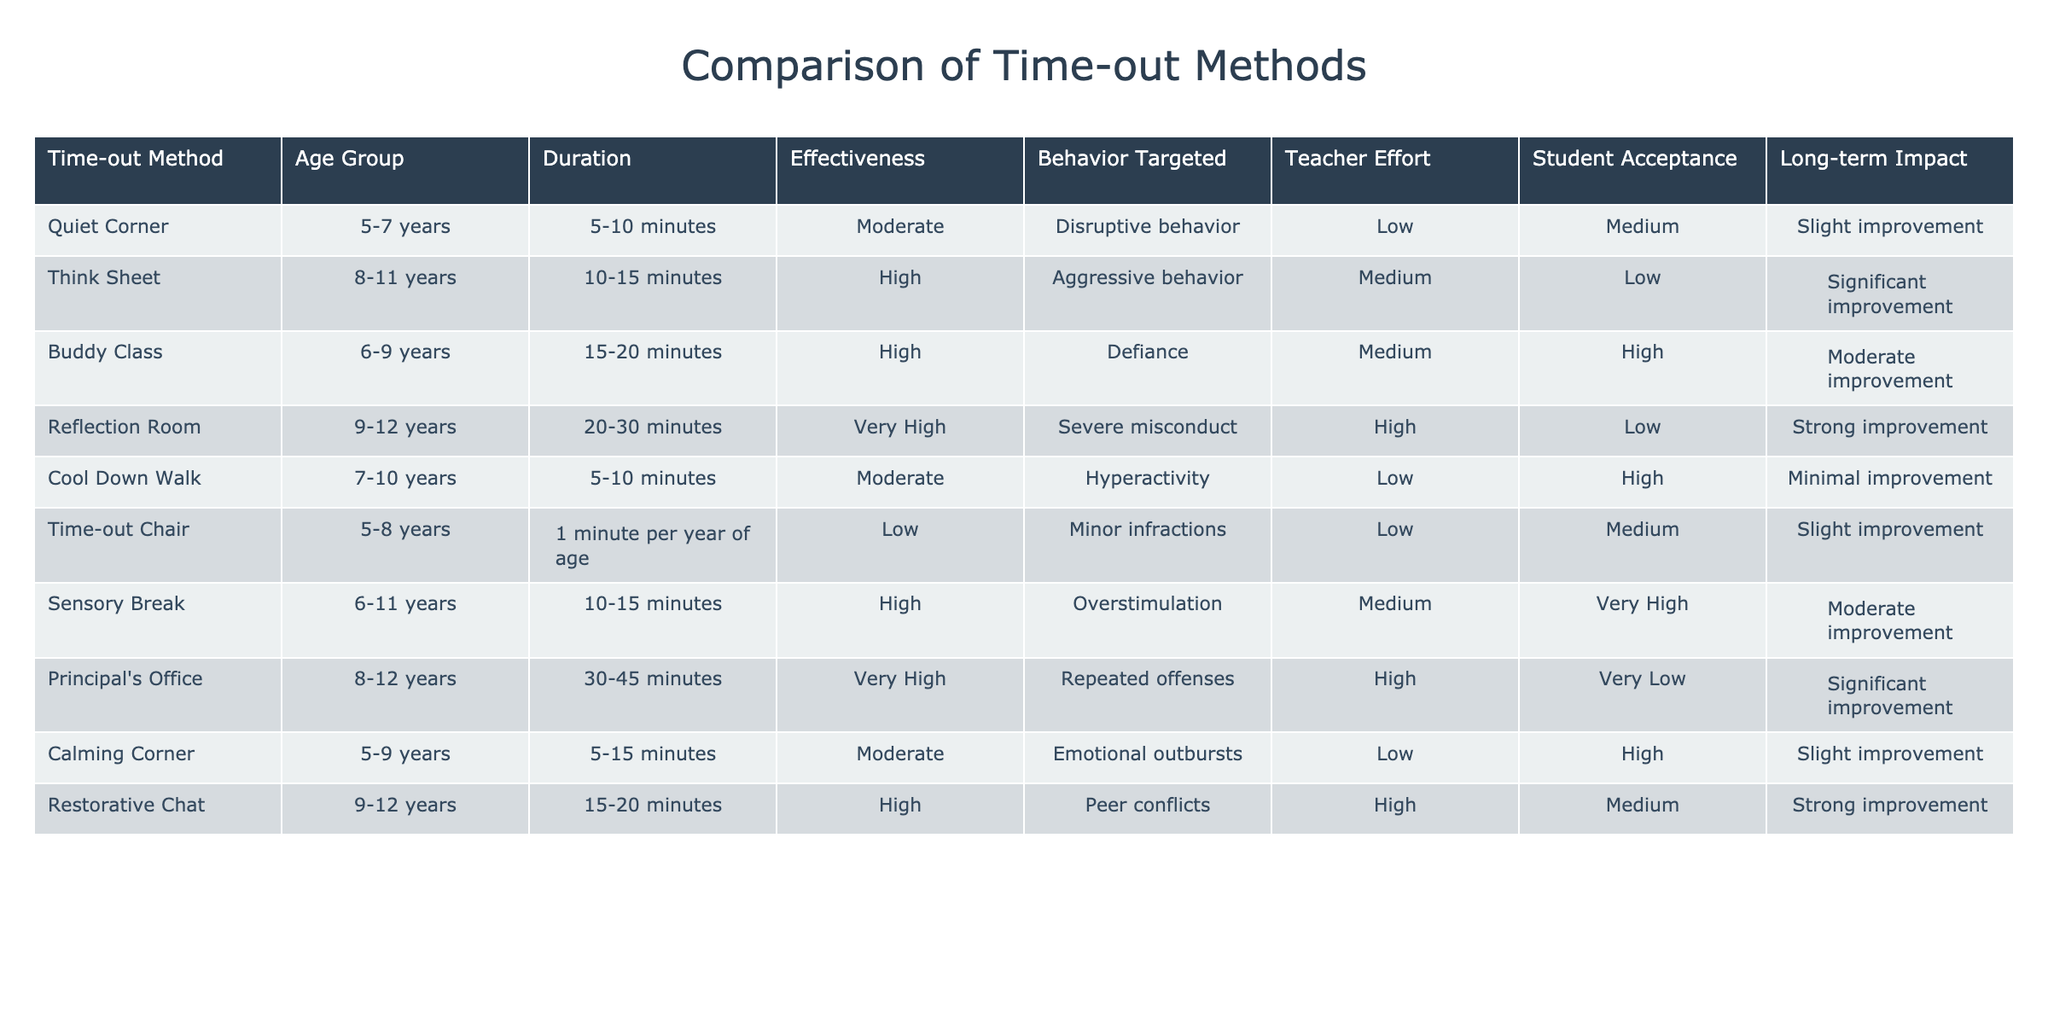What is the effectiveness rating for the Reflection Room method? The effectiveness of the Reflection Room method is categorized as "Very High." This is taken directly from the "Effectiveness" column next to the "Reflection Room" entry in the table.
Answer: Very High Which time-out method has the longest duration? The Principal's Office method has a duration of 30-45 minutes. This is the highest duration listed in the "Duration" column of the table, compared to all other methods.
Answer: Principal's Office Are students generally accepting of the Buddy Class method? No, the Buddy Class method has a "Low" rating for student acceptance, as indicated in the "Student Acceptance" column for that method.
Answer: No What is the average duration of time-out methods that target hyperactivity? Two methods target hyperactivity: Cool Down Walk (5-10 minutes) and Quiet Corner (5-10 minutes). The average of the duration range is calculated as (7.5 + 7.5) / 2 = 7.5 minutes.
Answer: 7.5 minutes Is there a time-out method that has a high effectiveness rating and very high student acceptance? No, there are no methods that have both "High" effectiveness and "Very High" student acceptance ratings in the table. Analyzing the data shows that the highest acceptance for a high effectiveness method is "Medium."
Answer: No 